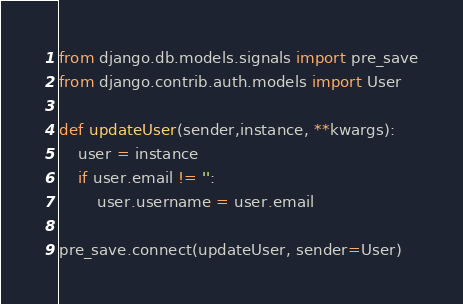Convert code to text. <code><loc_0><loc_0><loc_500><loc_500><_Python_>from django.db.models.signals import pre_save
from django.contrib.auth.models import User

def updateUser(sender,instance, **kwargs):
    user = instance
    if user.email != '':
        user.username = user.email

pre_save.connect(updateUser, sender=User)</code> 